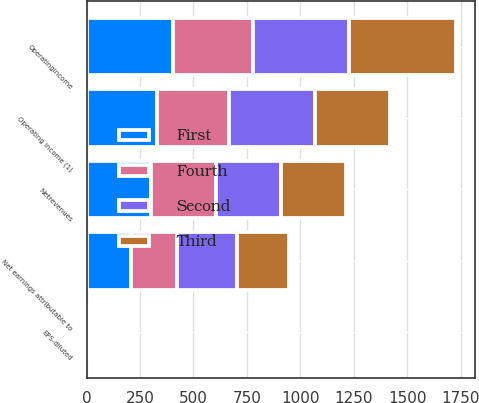Convert chart to OTSL. <chart><loc_0><loc_0><loc_500><loc_500><stacked_bar_chart><ecel><fcel>Netrevenues<fcel>Operatingincome<fcel>Net earnings attributable to<fcel>EPS-diluted<fcel>Operating income (1)<nl><fcel>Third<fcel>303.4<fcel>501.9<fcel>241.5<fcel>0.45<fcel>352.6<nl><fcel>Fourth<fcel>303.4<fcel>376.1<fcel>217.3<fcel>0.34<fcel>339.8<nl><fcel>First<fcel>303.4<fcel>402.2<fcel>207.9<fcel>0.36<fcel>327.7<nl><fcel>Second<fcel>303.4<fcel>448.3<fcel>278.9<fcel>0.47<fcel>399.3<nl></chart> 